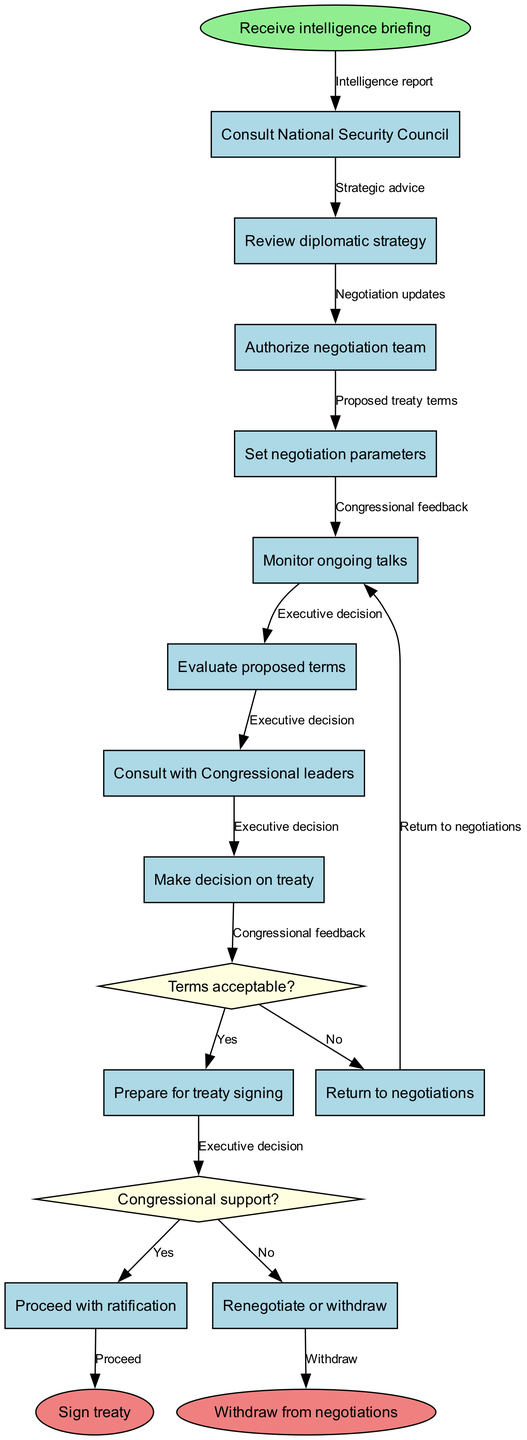What is the first activity in the diagram? The diagram begins with the initial node labeled "Receive intelligence briefing." This indicates that the workflow starts with receiving an intelligence update.
Answer: Receive intelligence briefing How many activities are present in the workflow? The diagram includes a total of eight activities that need to be performed during the negotiation process. These activities are listed in the activities section of the diagram.
Answer: Eight What happens if the proposed terms are acceptable? If the terms are acceptable, the workflow indicates that the next step is to "Prepare for treaty signing," as indicated in the decision node that pertains to the acceptability of the terms.
Answer: Prepare for treaty signing What is the outcome if congressional support is not gained? If congressional support is not obtained, the decision node indicates that the next step would be to "Renegotiate or withdraw," meaning that further discussions will occur or the treaty process might end.
Answer: Renegotiate or withdraw What activity follows the "Authorize negotiation team"? After "Authorize negotiation team," the workflow proceeds to the next activity, which is "Set negotiation parameters," indicating that setting parameters is a subsequent step in the negotiation process.
Answer: Set negotiation parameters What is the function of the decision node "Terms acceptable?" This decision node evaluates whether the proposed treaty terms meet acceptable standards. Based on the condition, the workflow will either proceed to prepare for treaty signing or return to negotiations.
Answer: Evaluates threshold for acceptance How many final nodes are present in the diagram? The diagram concludes with two final nodes: "Sign treaty" and "Withdraw from negotiations." These nodes represent the two possible endpoints of the workflow.
Answer: Two What edge connects the last activity to the first decision node? The edge that connects the last activity "Evaluate proposed terms" to the first decision node "Terms acceptable?" signifies the flow into the decision-making process regarding whether the proposed terms are satisfactory.
Answer: Proposed treaty terms 